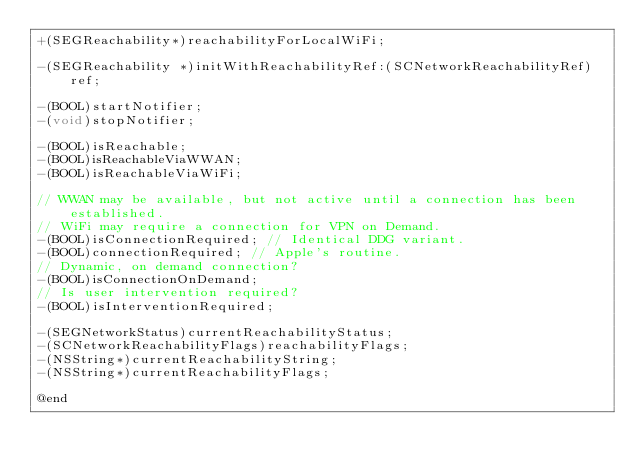Convert code to text. <code><loc_0><loc_0><loc_500><loc_500><_C_>+(SEGReachability*)reachabilityForLocalWiFi;

-(SEGReachability *)initWithReachabilityRef:(SCNetworkReachabilityRef)ref;

-(BOOL)startNotifier;
-(void)stopNotifier;

-(BOOL)isReachable;
-(BOOL)isReachableViaWWAN;
-(BOOL)isReachableViaWiFi;

// WWAN may be available, but not active until a connection has been established.
// WiFi may require a connection for VPN on Demand.
-(BOOL)isConnectionRequired; // Identical DDG variant.
-(BOOL)connectionRequired; // Apple's routine.
// Dynamic, on demand connection?
-(BOOL)isConnectionOnDemand;
// Is user intervention required?
-(BOOL)isInterventionRequired;

-(SEGNetworkStatus)currentReachabilityStatus;
-(SCNetworkReachabilityFlags)reachabilityFlags;
-(NSString*)currentReachabilityString;
-(NSString*)currentReachabilityFlags;

@end
</code> 